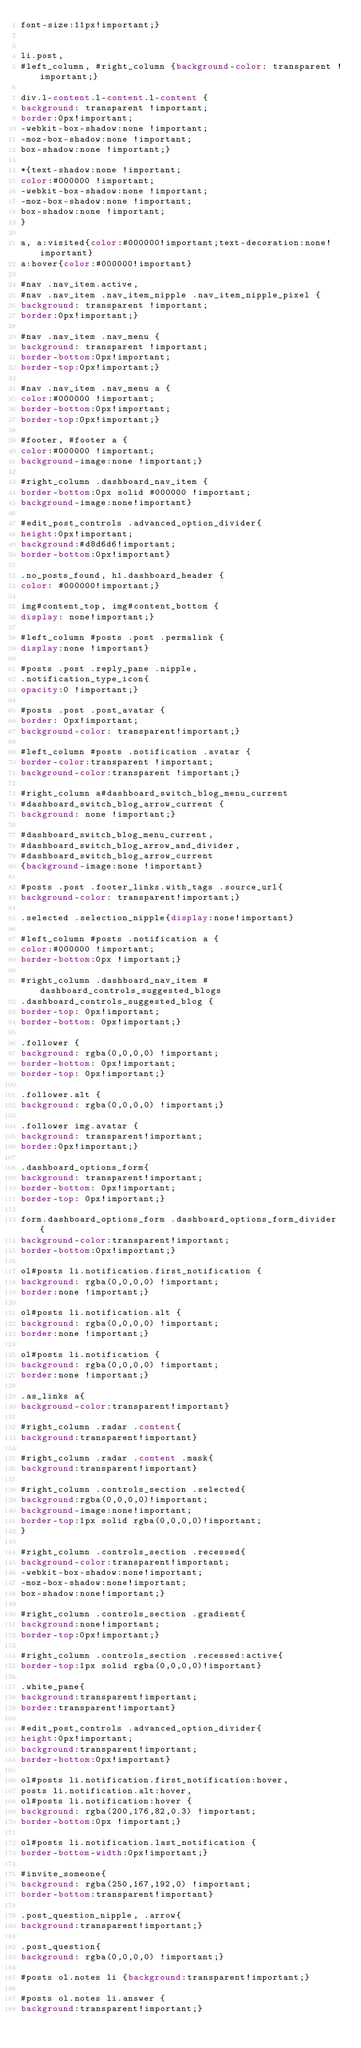<code> <loc_0><loc_0><loc_500><loc_500><_CSS_>font-size:11px!important;}


li.post,
#left_column, #right_column {background-color: transparent !important;}

div.l-content.l-content.l-content {
background: transparent !important;
border:0px!important;
-webkit-box-shadow:none !important;
-moz-box-shadow:none !important;
box-shadow:none !important;}

*{text-shadow:none !important; 
color:#000000 !important;
-webkit-box-shadow:none !important;
-moz-box-shadow:none !important;
box-shadow:none !important;
}

a, a:visited{color:#000000!important;text-decoration:none!important}
a:hover{color:#000000!important}

#nav .nav_item.active,
#nav .nav_item .nav_item_nipple .nav_item_nipple_pixel {
background: transparent !important;
border:0px!important;}

#nav .nav_item .nav_menu {
background: transparent !important;
border-bottom:0px!important;
border-top:0px!important;}

#nav .nav_item .nav_menu a {
color:#000000 !important;
border-bottom:0px!important;
border-top:0px!important;}

#footer, #footer a {
color:#000000 !important;
background-image:none !important;}

#right_column .dashboard_nav_item {
border-bottom:0px solid #000000 !important;
background-image:none!important}

#edit_post_controls .advanced_option_divider{
height:0px!important;
background:#d8d6d6!important;
border-bottom:0px!important}

.no_posts_found, h1.dashboard_header {
color: #000000!important;}

img#content_top, img#content_bottom {
display: none!important;}

#left_column #posts .post .permalink {
display:none !important}

#posts .post .reply_pane .nipple,
.notification_type_icon{
opacity:0 !important;}

#posts .post .post_avatar {
border: 0px!important;
background-color: transparent!important;}

#left_column #posts .notification .avatar {
border-color:transparent !important;
background-color:transparent !important;}

#right_column a#dashboard_switch_blog_menu_current 
#dashboard_switch_blog_arrow_current {
background: none !important;}

#dashboard_switch_blog_menu_current,
#dashboard_switch_blog_arrow_and_divider,
#dashboard_switch_blog_arrow_current
{background-image:none !important}

#posts .post .footer_links.with_tags .source_url{
background-color: transparent!important;}

.selected .selection_nipple{display:none!important}

#left_column #posts .notification a {
color:#000000 !important;
border-bottom:0px !important;}

#right_column .dashboard_nav_item #dashboard_controls_suggested_blogs 
.dashboard_controls_suggested_blog {
border-top: 0px!important;
border-bottom: 0px!important;}

.follower {
background: rgba(0,0,0,0) !important;
border-bottom: 0px!important;
border-top: 0px!important;}

.follower.alt {
background: rgba(0,0,0,0) !important;}

.follower img.avatar {
background: transparent!important;
border:0px!important;}

.dashboard_options_form{
background: transparent!important;
border-bottom: 0px!important;
border-top: 0px!important;}

form.dashboard_options_form .dashboard_options_form_divider {
background-color:transparent!important;
border-bottom:0px!important;}

ol#posts li.notification.first_notification {
background: rgba(0,0,0,0) !important;
border:none !important;}

ol#posts li.notification.alt {
background: rgba(0,0,0,0) !important;
border:none !important;}

ol#posts li.notification {
background: rgba(0,0,0,0) !important;
border:none !important;}

.as_links a{
background-color:transparent!important}

#right_column .radar .content{
background:transparent!important}

#right_column .radar .content .mask{
background:transparent!important}

#right_column .controls_section .selected{
background:rgba(0,0,0,0)!important;
background-image:none!important;
border-top:1px solid rgba(0,0,0,0)!important;
}

#right_column .controls_section .recessed{
background-color:transparent!important;
-webkit-box-shadow:none!important;
-moz-box-shadow:none!important;
box-shadow:none!important;}

#right_column .controls_section .gradient{
background:none!important;
border-top:0px!important;}

#right_column .controls_section .recessed:active{
border-top:1px solid rgba(0,0,0,0)!important}

.white_pane{
background:transparent!important;
border:transparent!important}

#edit_post_controls .advanced_option_divider{
height:0px!important;
background:transparent!important;
border-bottom:0px!important}

ol#posts li.notification.first_notification:hover,
posts li.notification.alt:hover,
ol#posts li.notification:hover {
background: rgba(200,176,82,0.3) !important;
border-bottom:0px !important;}

ol#posts li.notification.last_notification {
border-bottom-width:0px!important;}

#invite_someone{
background: rgba(250,167,192,0) !important;
border-bottom:transparent!important}

.post_question_nipple, .arrow{
background:transparent!important;}

.post_question{
background: rgba(0,0,0,0) !important;}

#posts ol.notes li {background:transparent!important;}

#posts ol.notes li.answer {
background:transparent!important;}
</code> 